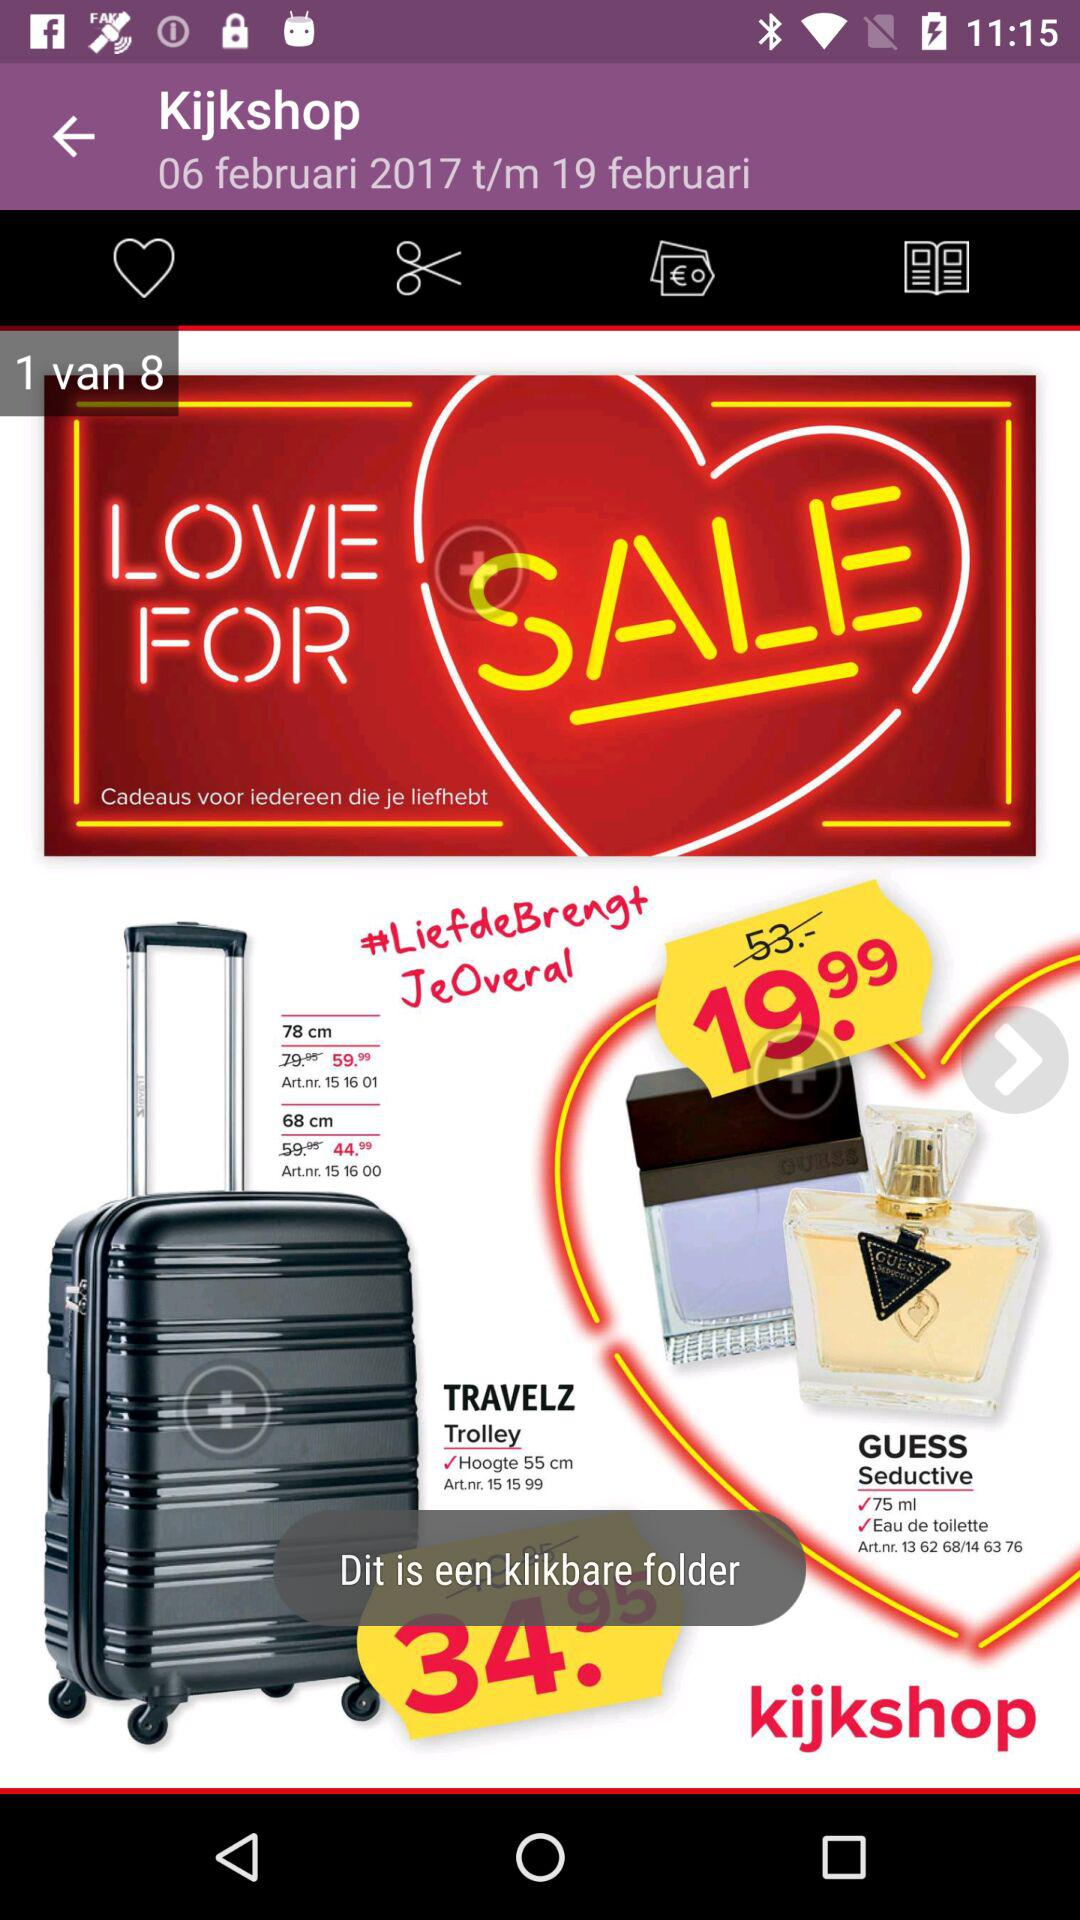How many products are on sale?
Answer the question using a single word or phrase. 2 